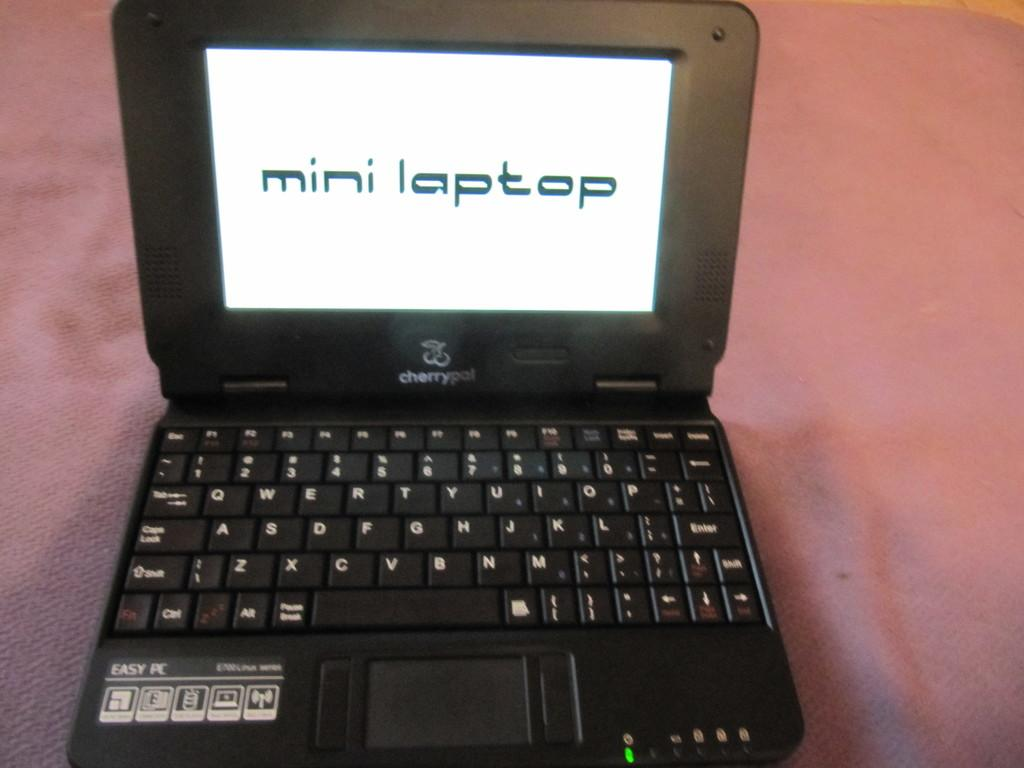<image>
Provide a brief description of the given image. A laptop's screen saver says "mini laptop" on it 